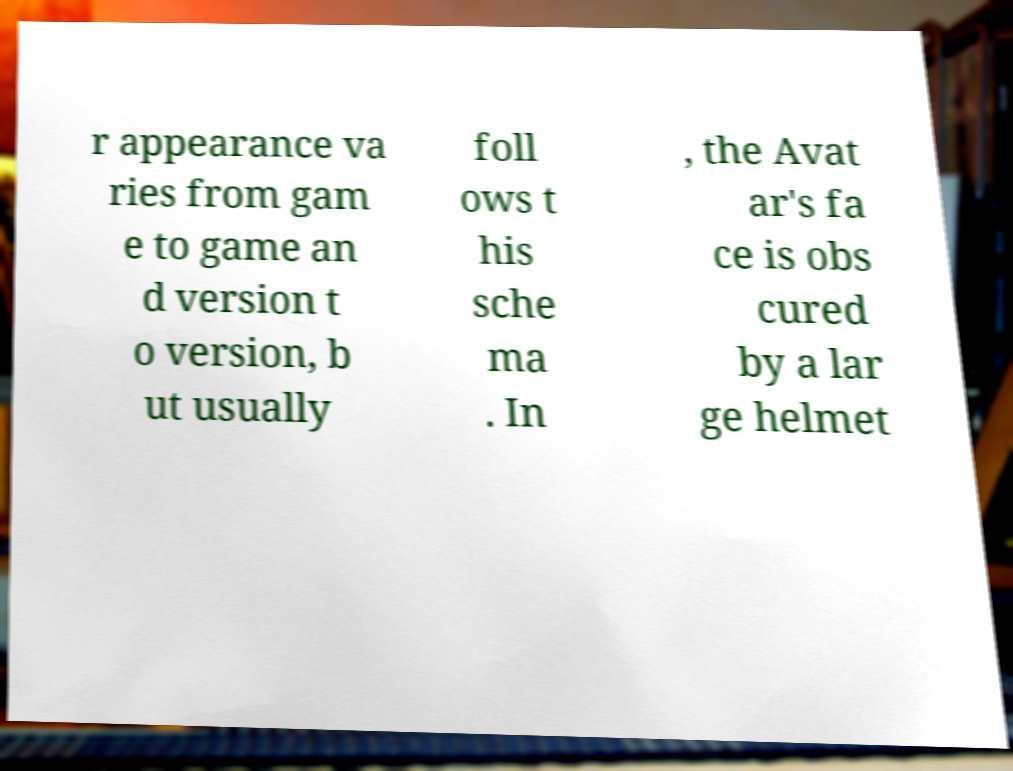Please identify and transcribe the text found in this image. r appearance va ries from gam e to game an d version t o version, b ut usually foll ows t his sche ma . In , the Avat ar's fa ce is obs cured by a lar ge helmet 